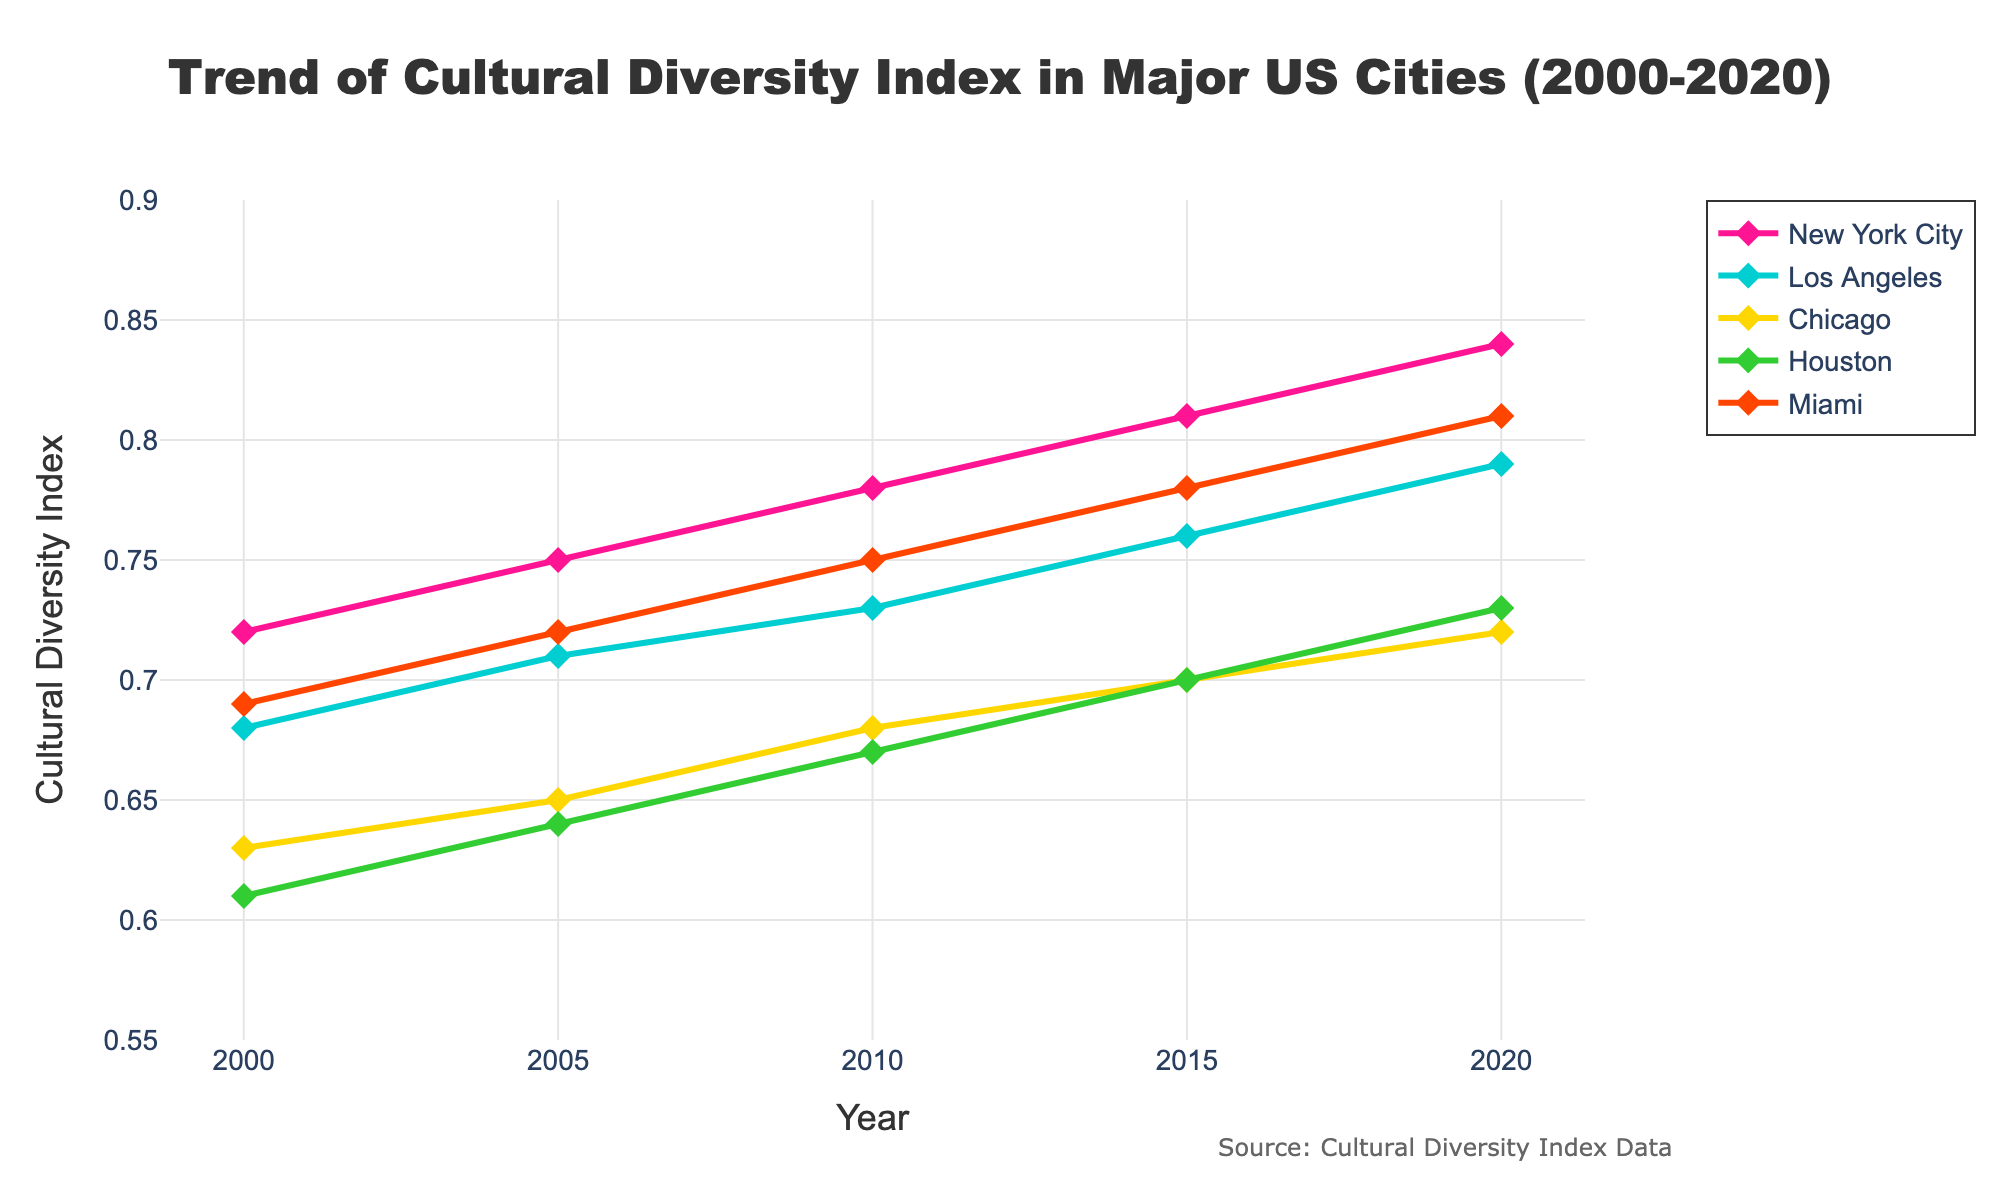What city had the highest Cultural Diversity Index in 2020? Look at the year 2020 on the x-axis and then find the city with the highest point on the y-axis. New York City has the highest point in 2020 at 0.84.
Answer: New York City Which city showed the greatest increase in their Cultural Diversity Index from 2000 to 2020? Compare the height difference of the index lines for each city from 2000 to 2020. New York City increased from 0.72 in 2000 to 0.84 in 2020, which is an increase of 0.12.
Answer: New York City Between Chicago and Miami, which city had a higher Cultural Diversity Index in 2015, and by how much? Look at the points for Chicago and Miami in 2015 on the chart. Chicago had an index of 0.70, and Miami had 0.78. The difference is 0.78 - 0.70 = 0.08.
Answer: Miami by 0.08 What is the average Cultural Diversity Index of Houston between the years 2000 and 2020? Calculate the average by summing the values for Houston over the years (0.61, 0.64, 0.67, 0.70, 0.73) and dividing by the number of years (5). (0.61 + 0.64 + 0.67 + 0.70 + 0.73) / 5 = 3.35 / 5 = 0.67
Answer: 0.67 In which year did Los Angeles surpass the Cultural Diversity Index of 0.75 for the first time? Track the data points for Los Angeles along the y-axis until it first exceeds 0.75. This happens between 2010 and 2015, and in 2015 the index is 0.76.
Answer: 2015 Comparing New York City and Houston, which city had a more consistent trend in their Cultural Diversity Index from 2000 to 2020? Look at the smoothness and slope of the lines for both cities. New York City's line appears to show a more steady increase without large fluctuations compared to Houston's.
Answer: New York City Which city had the smallest change in their Cultural Diversity Index from 2000 to 2020? Compare the start and end points for each city from the year 2000 to 2020. Chicago changed from 0.63 in 2000 to 0.72 in 2020, a difference of 0.09, which is the smallest discrepancy.
Answer: Chicago How did Miami's Cultural Diversity Index in 2005 compare to its index in 2010? Find the points for Miami in 2005 and 2010 on the chart. Miami had 0.72 in 2005 and 0.75 in 2010.
Answer: Increased by 0.03 What is the combined Cultural Diversity Index for Los Angeles and Chicago in 2010? Add the indices for Los Angeles and Chicago in 2010. Los Angeles's index is 0.73, and Chicago's is 0.68. Adding them: 0.73 + 0.68 = 1.41
Answer: 1.41 Between 2005 and 2010, which city had the highest growth in their Cultural Diversity Index? Check the increase in indices for each city from 2005 to 2010: New York City (0.75 to 0.78, ↑0.03), Los Angeles (0.71 to 0.73, ↑0.02), Chicago (0.65 to 0.68, ↑0.03), Houston (0.64 to 0.67, ↑0.03), Miami (0.72 to 0.75, ↑0.03). All cities had an equal increase of 0.03.
Answer: New York City, Chicago, Houston, Miami (Tie) 